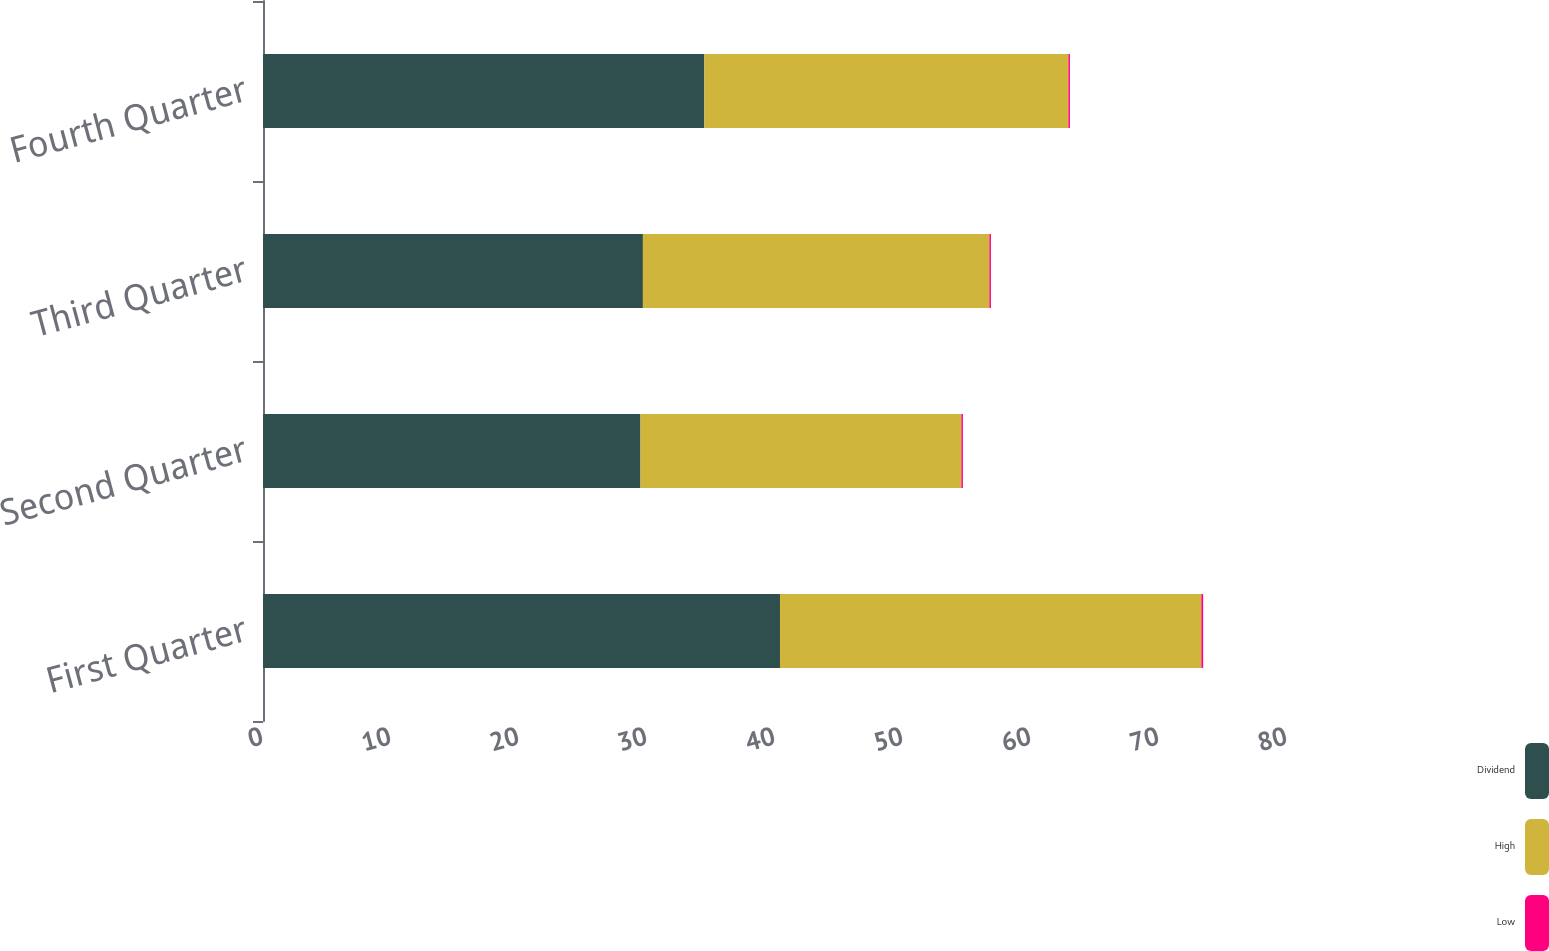Convert chart to OTSL. <chart><loc_0><loc_0><loc_500><loc_500><stacked_bar_chart><ecel><fcel>First Quarter<fcel>Second Quarter<fcel>Third Quarter<fcel>Fourth Quarter<nl><fcel>Dividend<fcel>40.39<fcel>29.49<fcel>29.68<fcel>34.48<nl><fcel>High<fcel>32.92<fcel>25.07<fcel>27.07<fcel>28.44<nl><fcel>Low<fcel>0.14<fcel>0.12<fcel>0.12<fcel>0.12<nl></chart> 